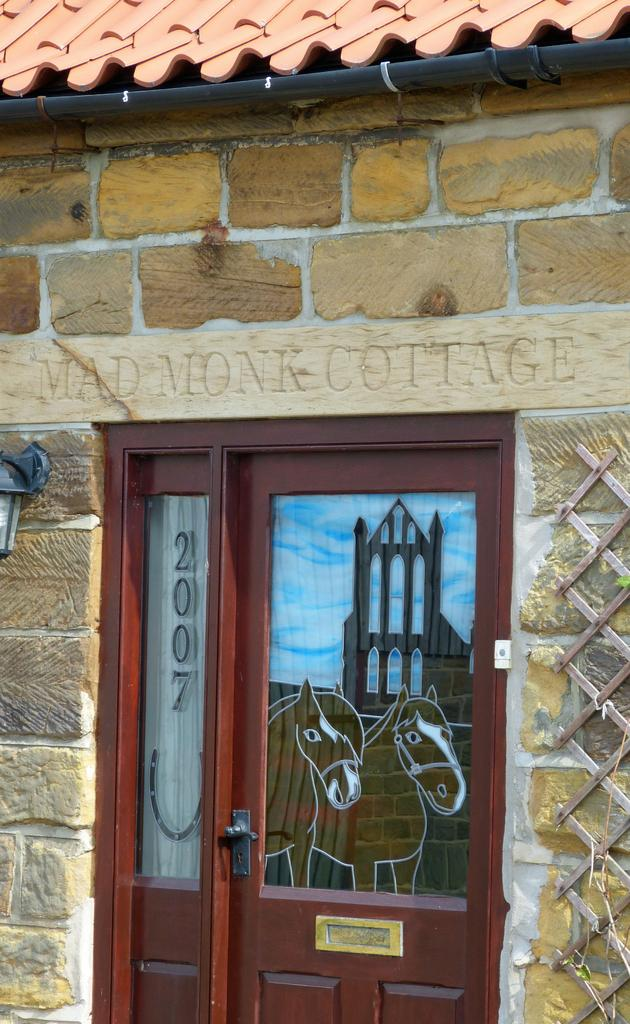What is the main object in the image? There is a door with glasses in the image. What can be seen on the right side of the image? There is a wall on the right side of the image. What can be seen on the left side of the image? There is a wall on the left side of the image. What is located at the top of the image? There is a roof at the top of the image, along with an iron object and a wall. How does the door express its feelings of hate in the image? The door does not express any feelings in the image, as it is an inanimate object. What type of bedroom can be seen in the image? There is no bedroom present in the image; it features a door with glasses and surrounding walls. 